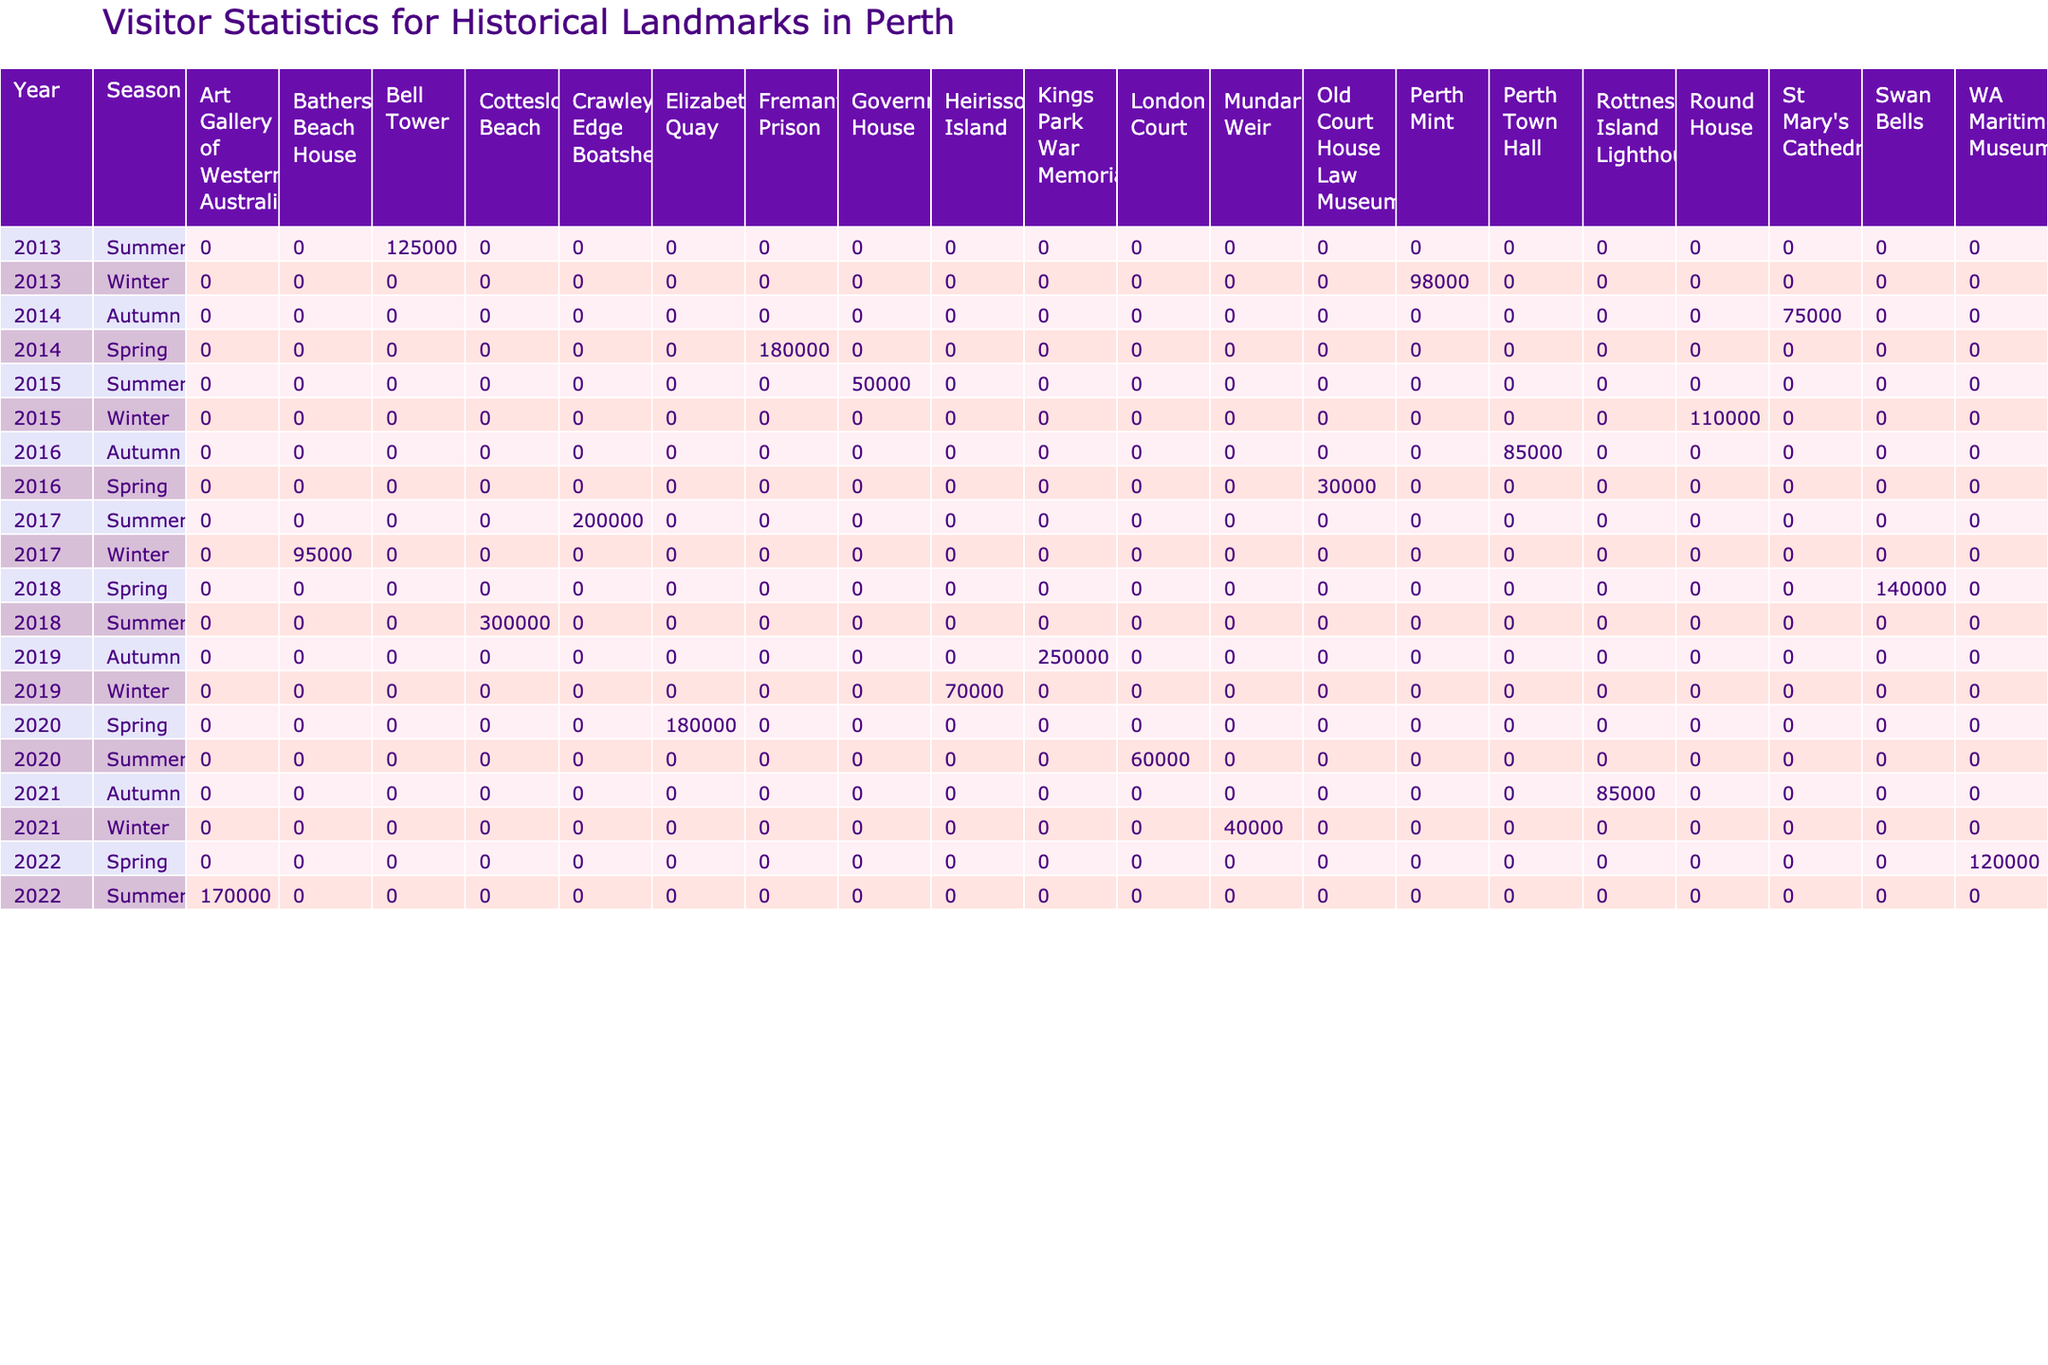What was the total number of visitors to the Bell Tower across all seasons in 2013? Referring to the table, the Bell Tower had 125,000 visitors in summer 2013, and there were no other seasonal visitors listed for it in that year. Therefore, the total number of visitors in that year is simply 125,000.
Answer: 125000 Which landmark had the highest visitor count in the summer season over the decade? Looking at the summer season data, the Cottesloe Beach had 300,000 visitors, which is higher than any other landmark's visitor count in the summer season for the entire decade.
Answer: Cottesloe Beach Was the Heritage Festival in 2014 associated with more visitors to Fremantle Prison than any other event in the data? In 2014, the Fremantle Prison had 180,000 visitors during the Heritage Festival. None of the events listed for other landmarks, either in 2014 or any other year, surpassed this number. Therefore, yes, it was the highest event visitor count.
Answer: Yes What is the average number of visitors to the Perth Mint across both listed years? The Perth Mint had 98,000 visitors in 2013 and none reported in 2014. Thus, the average is calculated as total visitors (98,000) divided by the number of years it was counted (1), which equals 98,000.
Answer: 98000 Which season generally attracted more visitors: summer or winter? By comparing totals from each season over the decade, the summer had a total of 1,042,000 visitors (from various landmarks) while winter had fewer visitors, totaling 400,000. Thus, overall, summer attracted more visitors.
Answer: Summer What was the difference in visitor numbers between the highest and lowest landmark records in 2020? In 2020, Elizabeth Quay had 180,000 visitors while London Court had 60,000 visitors. The difference in visitor numbers is 180,000 - 60,000 = 120,000.
Answer: 120000 Did the Swan Bells have more visitors than the Crawley Edge Boatshed in any year? The Swan Bells had 140,000 visitors in 2018, while the Crawley Edge Boatshed had 200,000 visitors in 2017. Since 140,000 is less than 200,000, the answer is no, the Swan Bells did not have more visitors in any year compared to the Crawley Edge Boatshed.
Answer: No Identify the year with the most visitors in total for all landmarks combined. To find this, I need to sum the visitors for each year: 2013 (223,000), 2014 (255,000), 2015 (160,000), 2016 (130,000), 2017 (295,000), 2018 (440,000), 2019 (320,000), 2020 (240,000), 2021 (125,000), 2022 (290,000). The highest total is in 2018 with 440,000 visitors.
Answer: 2018 What was the peak number of visitors to any single landmark in a specific event? The peak number of visitors was 300,000 at Cottesloe Beach during the Sculpture by the Sea event in summer 2018, which is higher than any other records in this dataset.
Answer: 300000 